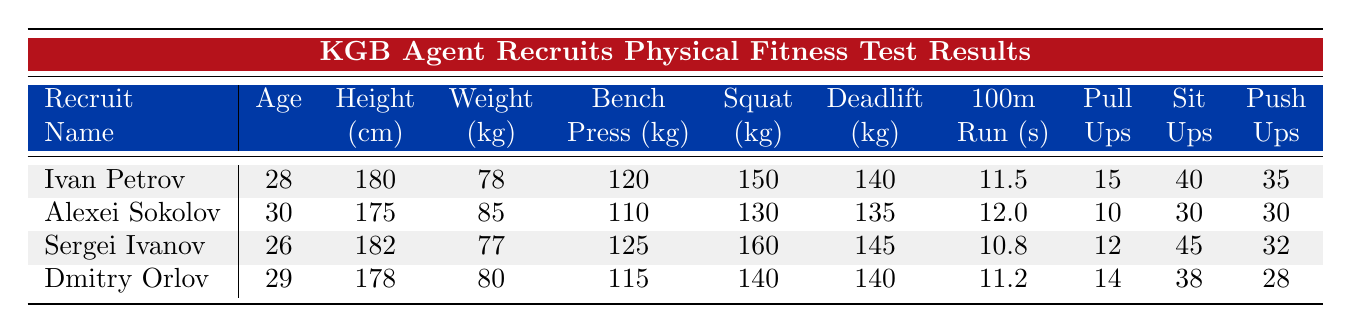What is the highest bench press weight among the recruits? From the table, I compare the Bench Press values: Ivan Petrov has 120 kg, Alexei Sokolov has 110 kg, Sergei Ivanov has 125 kg, and Dmitry Orlov has 115 kg. The maximum value is 125 kg from Sergei Ivanov.
Answer: 125 kg Which recruit has the best time in the 100m run? Looking at the Run 100m seconds: Ivan Petrov took 11.5 seconds, Alexei Sokolov took 12.0 seconds, Sergei Ivanov took 10.8 seconds, and Dmitry Orlov took 11.2 seconds. The lowest time is 10.8 seconds by Sergei Ivanov.
Answer: Sergei Ivanov What is the average number of sit-ups completed by the recruits? Total sit-ups from the table: Ivan Petrov 40, Alexei Sokolov 30, Sergei Ivanov 45, and Dmitry Orlov 38. Sum is 40 + 30 + 45 + 38 = 153. There are 4 recruits, so the average is 153 / 4 = 38.25.
Answer: 38.25 Did any of the recruits achieve more than 15 pull-ups? Checking the Pull Ups count: Ivan Petrov has 15, Alexei Sokolov has 10, Sergei Ivanov has 12, and Dmitry Orlov has 14. None exceeded 15, confirming that no recruit reached over this number.
Answer: No Who is the heaviest recruit and what is their weight? The weights listed are: Ivan Petrov 78 kg, Alexei Sokolov 85 kg, Sergei Ivanov 77 kg, and Dmitry Orlov 80 kg. Alexei Sokolov at 85 kg is the heaviest of the recruits.
Answer: Alexei Sokolov, 85 kg What is the difference in squat weight between the strongest and weakest recruits? The squat weights are Ivan Petrov 150 kg, Alexei Sokolov 130 kg, Sergei Ivanov 160 kg, and Dmitry Orlov 140 kg. The highest is 160 kg by Sergei Ivanov and the lowest is 130 kg by Alexei Sokolov. The difference is 160 - 130 = 30 kg.
Answer: 30 kg Which recruit is the youngest and what is their age? The ages are: Ivan Petrov 28, Alexei Sokolov 30, Sergei Ivanov 26, and Dmitry Orlov 29. The youngest is Sergei Ivanov at 26 years old.
Answer: Sergei Ivanov, 26 years old How many total push-ups did all recruits complete combined? Add the Push Ups count: Ivan Petrov 35, Alexei Sokolov 30, Sergei Ivanov 32, and Dmitry Orlov 28. Their total is 35 + 30 + 32 + 28 = 125.
Answer: 125 Which recruit has a higher weight, Ivan Petrov or Dmitry Orlov? Their weights are: Ivan Petrov 78 kg and Dmitry Orlov 80 kg. Dmitry Orlov is 2 kg heavier than Ivan Petrov.
Answer: Dmitry Orlov is heavier 